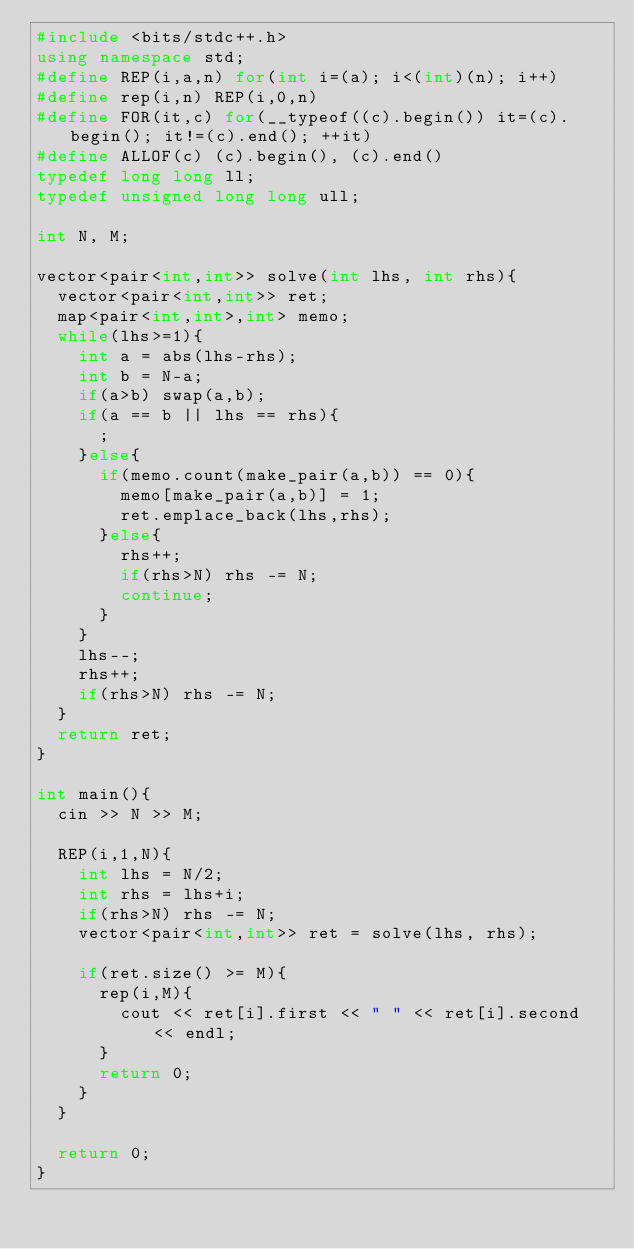Convert code to text. <code><loc_0><loc_0><loc_500><loc_500><_C++_>#include <bits/stdc++.h>
using namespace std;
#define REP(i,a,n) for(int i=(a); i<(int)(n); i++)
#define rep(i,n) REP(i,0,n)
#define FOR(it,c) for(__typeof((c).begin()) it=(c).begin(); it!=(c).end(); ++it)
#define ALLOF(c) (c).begin(), (c).end()
typedef long long ll;
typedef unsigned long long ull;

int N, M;

vector<pair<int,int>> solve(int lhs, int rhs){
  vector<pair<int,int>> ret;
  map<pair<int,int>,int> memo;
  while(lhs>=1){
    int a = abs(lhs-rhs);
    int b = N-a;
    if(a>b) swap(a,b);
    if(a == b || lhs == rhs){
      ;
    }else{
      if(memo.count(make_pair(a,b)) == 0){
        memo[make_pair(a,b)] = 1;
        ret.emplace_back(lhs,rhs);
      }else{
        rhs++;
        if(rhs>N) rhs -= N;
        continue;
      }
    }
    lhs--;
    rhs++;
    if(rhs>N) rhs -= N;
  }
  return ret;
}

int main(){
  cin >> N >> M;

  REP(i,1,N){
    int lhs = N/2;
    int rhs = lhs+i;
    if(rhs>N) rhs -= N;
    vector<pair<int,int>> ret = solve(lhs, rhs);
    
    if(ret.size() >= M){
      rep(i,M){
        cout << ret[i].first << " " << ret[i].second << endl;
      }
      return 0;
    }
  }
  
  return 0;
}
</code> 